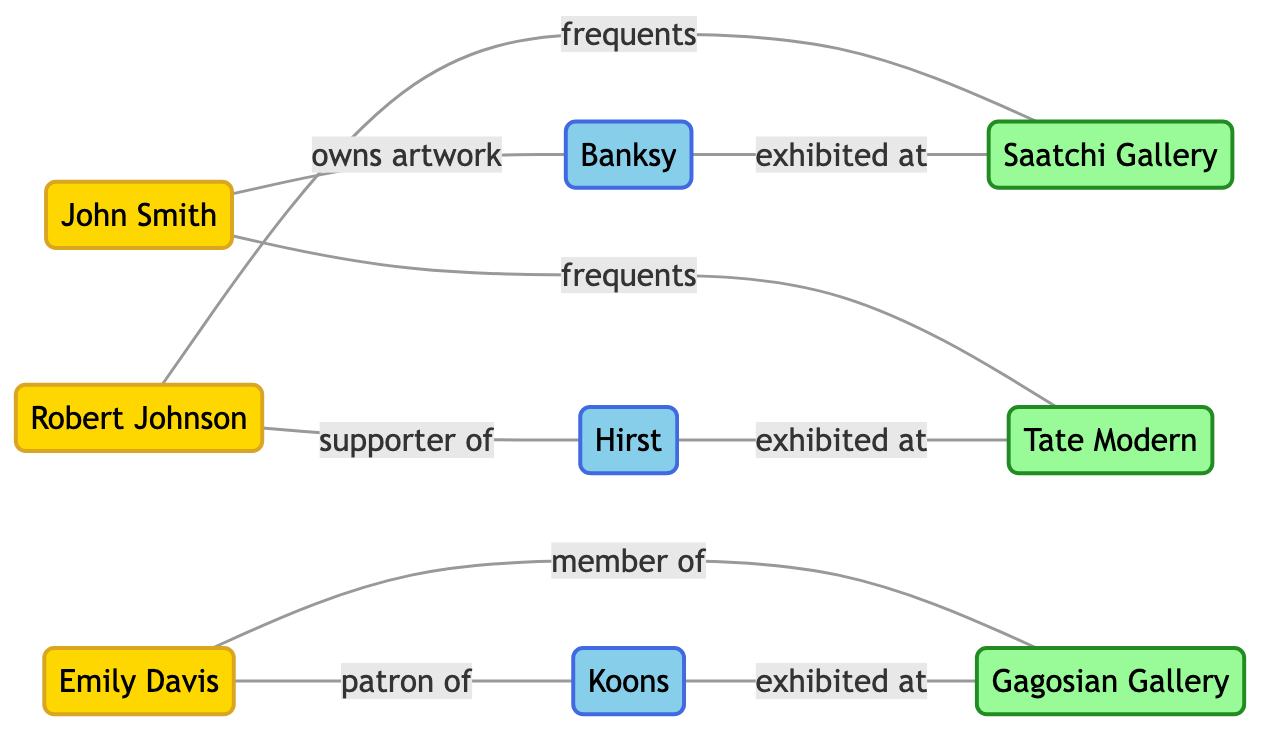What is the total number of nodes in the diagram? The diagram contains a total of 9 nodes, comprising 3 collectors, 3 artists, and 3 galleries.
Answer: 9 Which collector is a patron of Koons? The diagram shows that Emily Davis is connected to Koons with the relationship "patron of," indicating her support for the artist.
Answer: Emily Davis How many connections does Banksy have? In the diagram, Banksy has two connections: one with John Smith (owns artwork) and one with Saatchi Gallery (exhibited at), resulting in a total of two links.
Answer: 2 Which gallery does Robert Johnson frequent? The diagram indicates that Robert Johnson is connected to Saatchi Gallery with the relationship "frequents," showing his regular visit to that gallery.
Answer: Saatchi Gallery How many collectors are associated with Tate Modern? Reviewing the diagram, Tate Modern has connections with John Smith (frequents) and Hirst (exhibited at), but John Smith is the only collector directly associated with it, resulting in one collector.
Answer: 1 Which artist does John Smith own artwork from? The diagram directly states that John Smith has a connection with Banksy through the relationship "owns artwork," establishing this ownership clearly.
Answer: Banksy What type of relationship connects Emily Davis to Gagosian Gallery? The relationship between Emily Davis and Gagosian Gallery is defined as "member of," showing her affiliation with that gallery.
Answer: member of Which artist is supported by Robert Johnson? The diagram shows that Robert Johnson has a relationship labeled "supporter of" with Hirst, indicating his backing for the artist.
Answer: Hirst How many edges (connections) are there in total? Counting all the connections in the diagram, we find that there are 9 distinct links: 6 between collectors and artists or galleries, and 3 among artists and galleries.
Answer: 9 